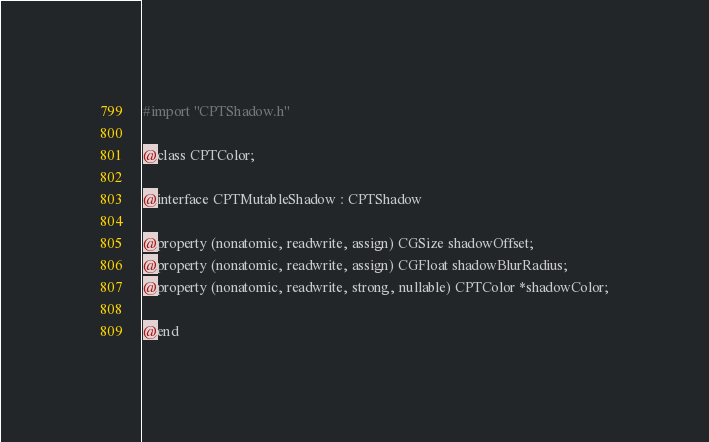Convert code to text. <code><loc_0><loc_0><loc_500><loc_500><_C_>#import "CPTShadow.h"

@class CPTColor;

@interface CPTMutableShadow : CPTShadow

@property (nonatomic, readwrite, assign) CGSize shadowOffset;
@property (nonatomic, readwrite, assign) CGFloat shadowBlurRadius;
@property (nonatomic, readwrite, strong, nullable) CPTColor *shadowColor;

@end
</code> 